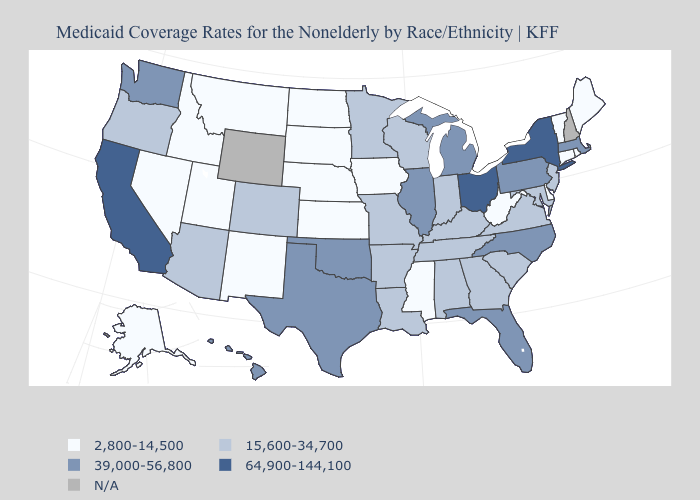Name the states that have a value in the range 2,800-14,500?
Give a very brief answer. Alaska, Connecticut, Delaware, Idaho, Iowa, Kansas, Maine, Mississippi, Montana, Nebraska, Nevada, New Mexico, North Dakota, Rhode Island, South Dakota, Utah, Vermont, West Virginia. Name the states that have a value in the range 2,800-14,500?
Concise answer only. Alaska, Connecticut, Delaware, Idaho, Iowa, Kansas, Maine, Mississippi, Montana, Nebraska, Nevada, New Mexico, North Dakota, Rhode Island, South Dakota, Utah, Vermont, West Virginia. What is the value of Massachusetts?
Keep it brief. 39,000-56,800. What is the value of Kentucky?
Concise answer only. 15,600-34,700. Does California have the highest value in the West?
Quick response, please. Yes. What is the lowest value in the USA?
Answer briefly. 2,800-14,500. Which states have the highest value in the USA?
Concise answer only. California, New York, Ohio. Is the legend a continuous bar?
Short answer required. No. What is the value of Massachusetts?
Answer briefly. 39,000-56,800. What is the lowest value in the South?
Answer briefly. 2,800-14,500. Among the states that border Illinois , which have the highest value?
Answer briefly. Indiana, Kentucky, Missouri, Wisconsin. What is the value of Louisiana?
Keep it brief. 15,600-34,700. Name the states that have a value in the range 15,600-34,700?
Answer briefly. Alabama, Arizona, Arkansas, Colorado, Georgia, Indiana, Kentucky, Louisiana, Maryland, Minnesota, Missouri, New Jersey, Oregon, South Carolina, Tennessee, Virginia, Wisconsin. How many symbols are there in the legend?
Keep it brief. 5. 